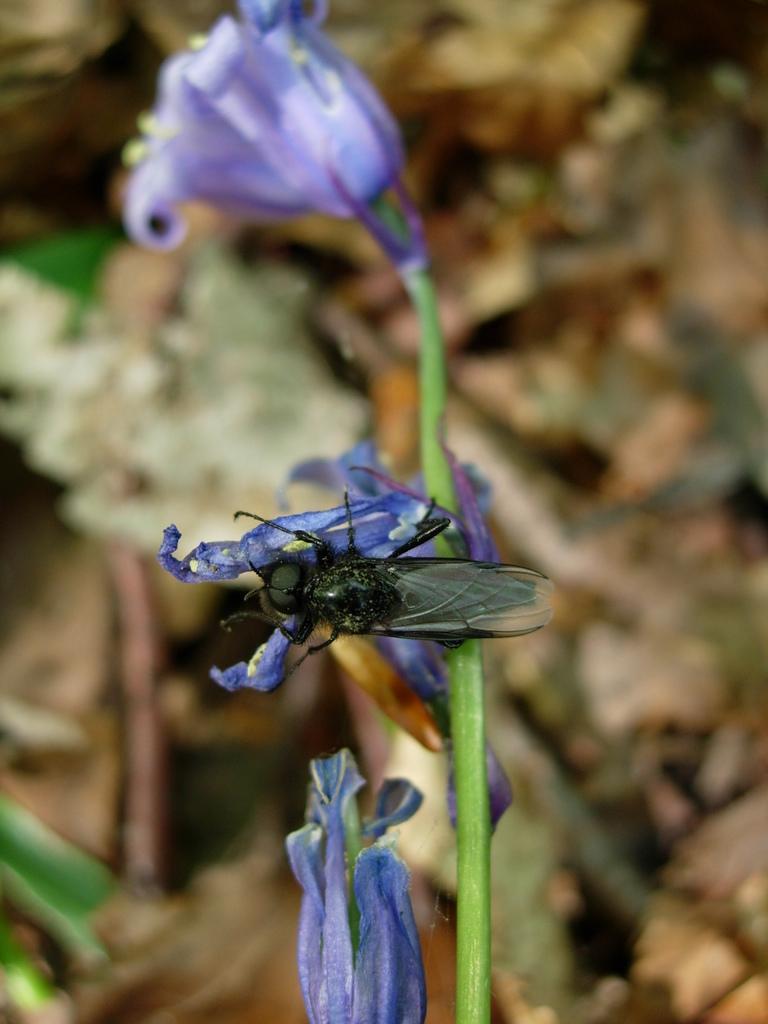How would you summarize this image in a sentence or two? In the image there is a stem with flowers. There is an insect on the flower. Behind the stem there is a blur background. 